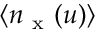Convert formula to latex. <formula><loc_0><loc_0><loc_500><loc_500>\langle n _ { x } ( u ) \rangle</formula> 